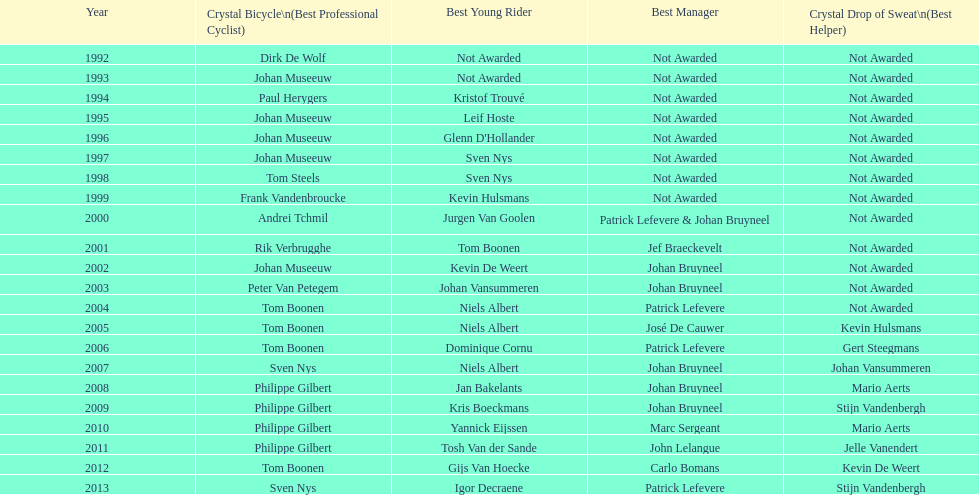Who has received the most best young rider honors? Niels Albert. 